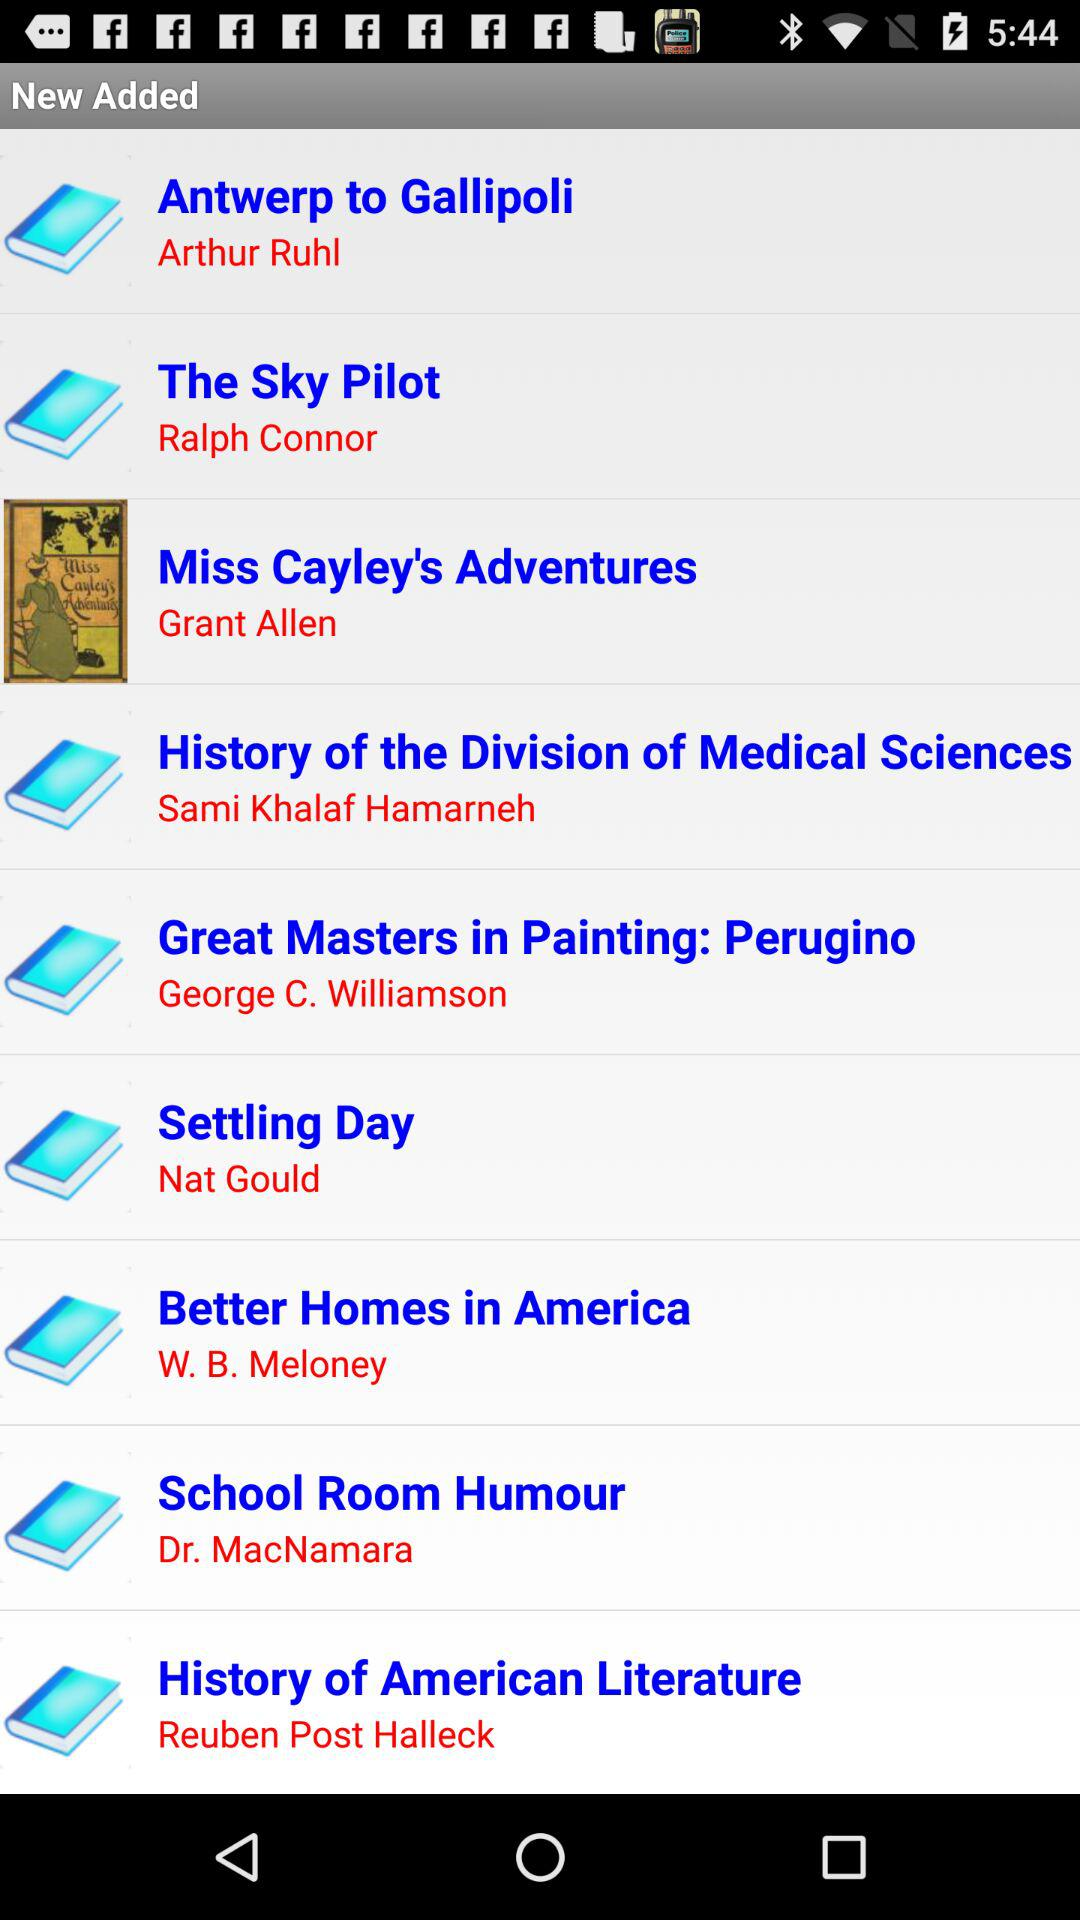What is the name of the author of the book "The Sky Pilot"? The name of the author of the book "The Sky Pilot" is Ralph Connor. 